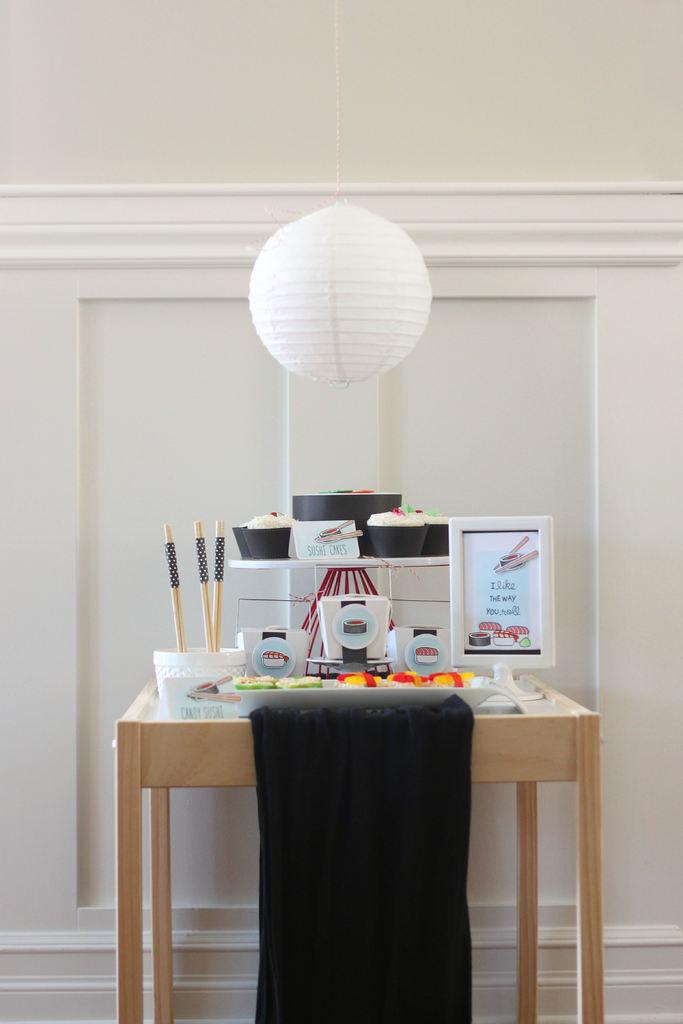<image>
Create a compact narrative representing the image presented. Next to the sushi on the table is a sign that says "I like the way you roll". 